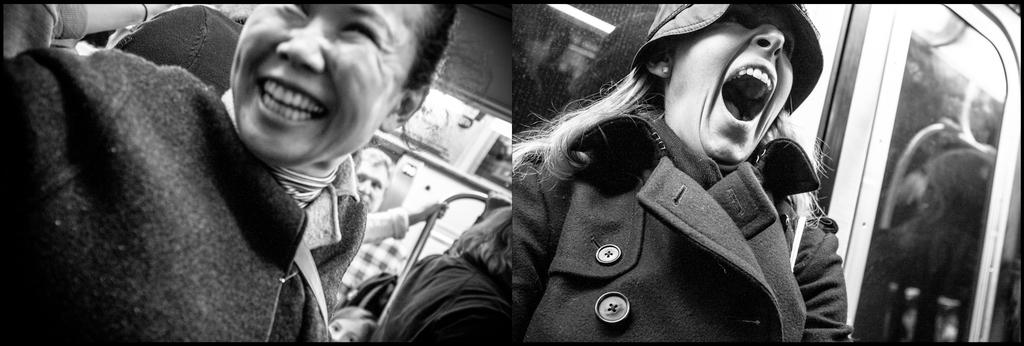What is the color scheme of the image? The image is black and white. What type of picture can be seen in the image? There is a collage picture of people in the image. What level of milk is present in the image? There is no milk present in the image. How many straws can be seen in the image? There are no straws visible in the image. 